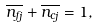<formula> <loc_0><loc_0><loc_500><loc_500>\overline { n _ { f j } } + \overline { n _ { c j } } = 1 ,</formula> 